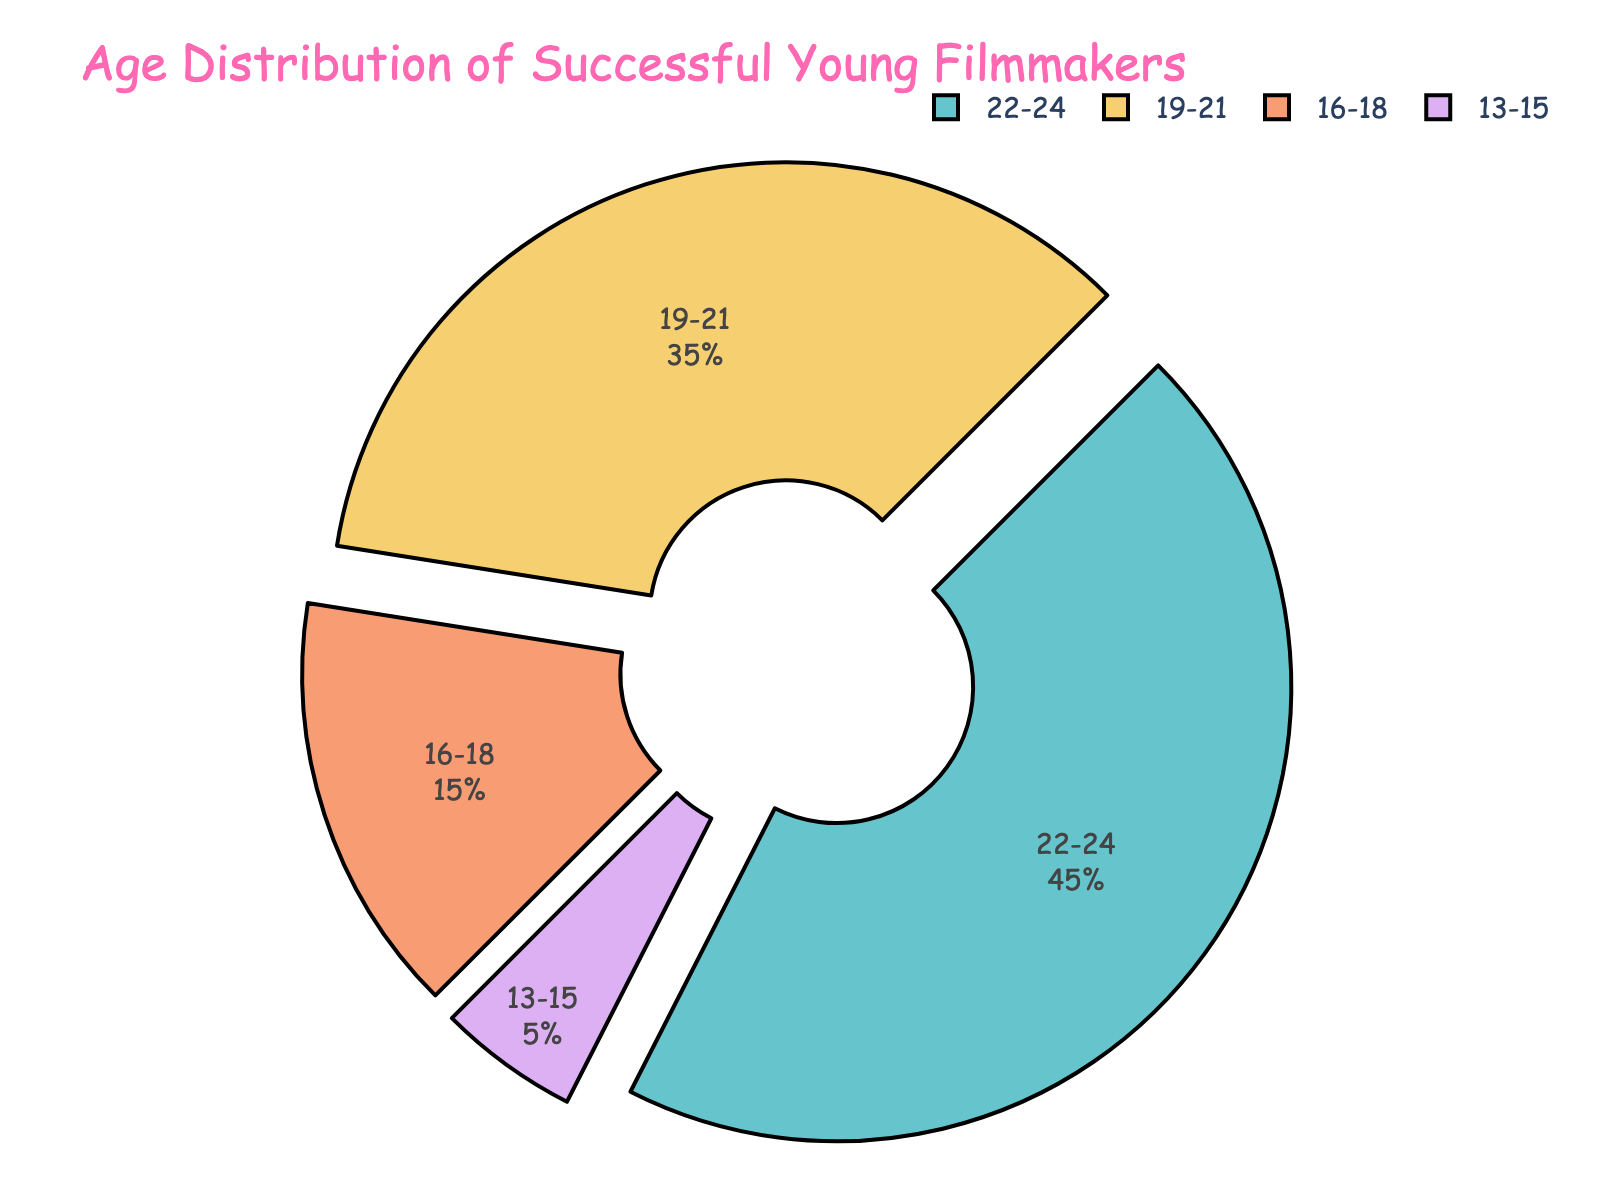What's the largest age group among successful young filmmakers under 25? The figure shows the age distribution, and we need to identify the largest segment. The "22-24" age group constitutes 45%, which is the highest among all age groups.
Answer: 22-24 How much more popular is the "19-21" age group compared to the "16-18" group? To find this out, we look at the percentages for both age groups and subtract the smaller from the larger. The "19-21" group is at 35% and the "16-18" group is at 15%. The difference is 35% - 15% = 20%.
Answer: 20% What proportion of successful young filmmakers are aged 19 or older? This requires summing up the percentages for age groups 19-21 and 22-24. Thus, 35% (19-21) + 45% (22-24) = 80%.
Answer: 80% How does the "13-15" age group's percentage compare to the total percentage of the other groups combined? The "13-15" group is 5%. The total for the other groups is 95% (100% - 5%). This shows that the "13-15" group is much smaller compared to the others combined.
Answer: 5% vs 95% Which age group has the least representation among successful young filmmakers under 25? From the figure, the "13-15" group constitutes only 5%, which is the least compared to the other groups.
Answer: 13-15 What is the combined percentage of the two smallest age groups? The two smallest age groups are "13-15" and "16-18". Adding their percentages gives 5% + 15% = 20%.
Answer: 20% If you combine the "16-18" and "22-24" age groups, how many times larger is their combined percentage compared to the "13-15" group? The combined percentage of "16-18" and "22-24" is 15% + 45% = 60%. To find how many times larger this is than the "13-15" group at 5%, we divide 60% by 5%, giving 60/5 = 12 times.
Answer: 12 times 